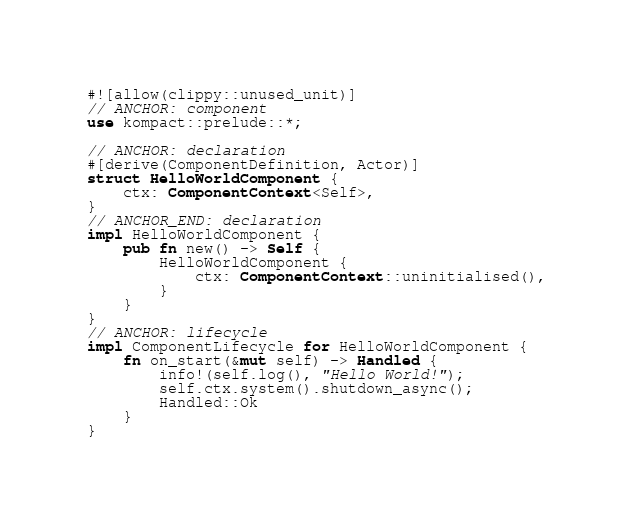<code> <loc_0><loc_0><loc_500><loc_500><_Rust_>#![allow(clippy::unused_unit)]
// ANCHOR: component
use kompact::prelude::*;

// ANCHOR: declaration
#[derive(ComponentDefinition, Actor)]
struct HelloWorldComponent {
    ctx: ComponentContext<Self>,
}
// ANCHOR_END: declaration
impl HelloWorldComponent {
    pub fn new() -> Self {
        HelloWorldComponent {
            ctx: ComponentContext::uninitialised(),
        }
    }
}
// ANCHOR: lifecycle
impl ComponentLifecycle for HelloWorldComponent {
    fn on_start(&mut self) -> Handled {
        info!(self.log(), "Hello World!");
        self.ctx.system().shutdown_async();
        Handled::Ok
    }
}</code> 